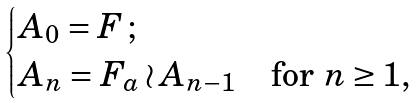<formula> <loc_0><loc_0><loc_500><loc_500>\begin{cases} A _ { 0 } = F \, ; \\ A _ { n } = F _ { a } \wr A _ { n - 1 } & \text {for } n \geq 1 , \end{cases}</formula> 